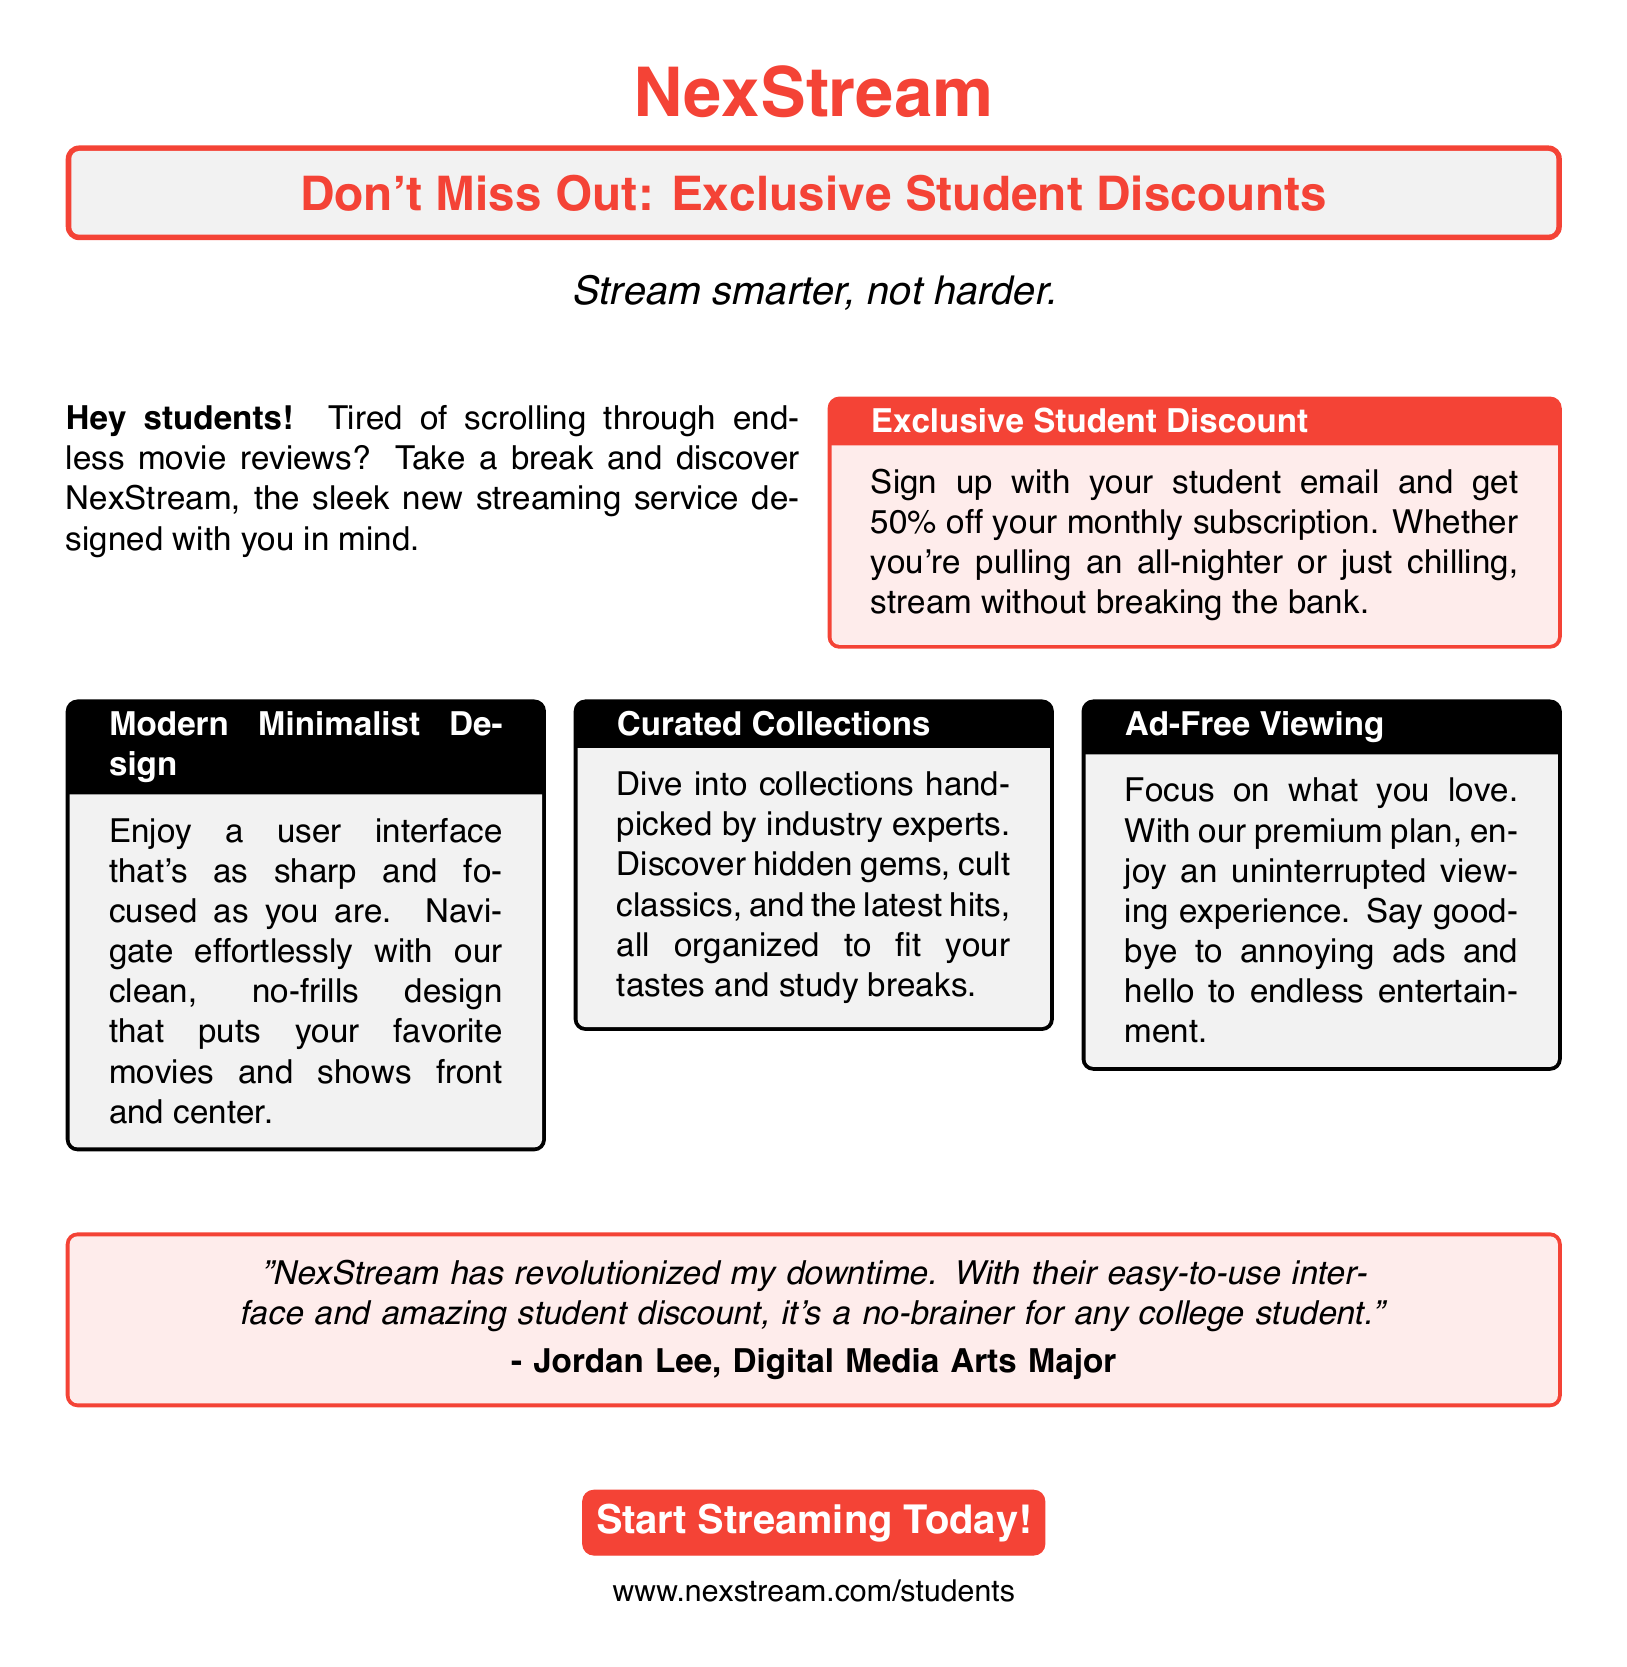What is the name of the streaming service? The name of the streaming service is mentioned prominently at the top of the document.
Answer: NexStream What is the discount percentage for students? The advertisement states the specific percentage off for students.
Answer: 50% What is the main color used in the advertisement? The advertisement prominently features a specific color, as seen in the title and boxes.
Answer: Red Who is quoted in the advertisement? The advertisement includes a testimonial from a specific individual.
Answer: Jordan Lee What type of design does NexStream feature? The advertisement describes the design style used for the streaming service.
Answer: Modern Minimalist What is the website for students to sign up? The advertisement provides a specific URL for student sign-ups.
Answer: www.nexstream.com/students What are the curated collections designed for? The advertisement specifies the audience for the curated collections.
Answer: Students How does NexStream enhance the viewing experience? The advertisement highlights a key feature that improves viewing for users.
Answer: Ad-Free Viewing 